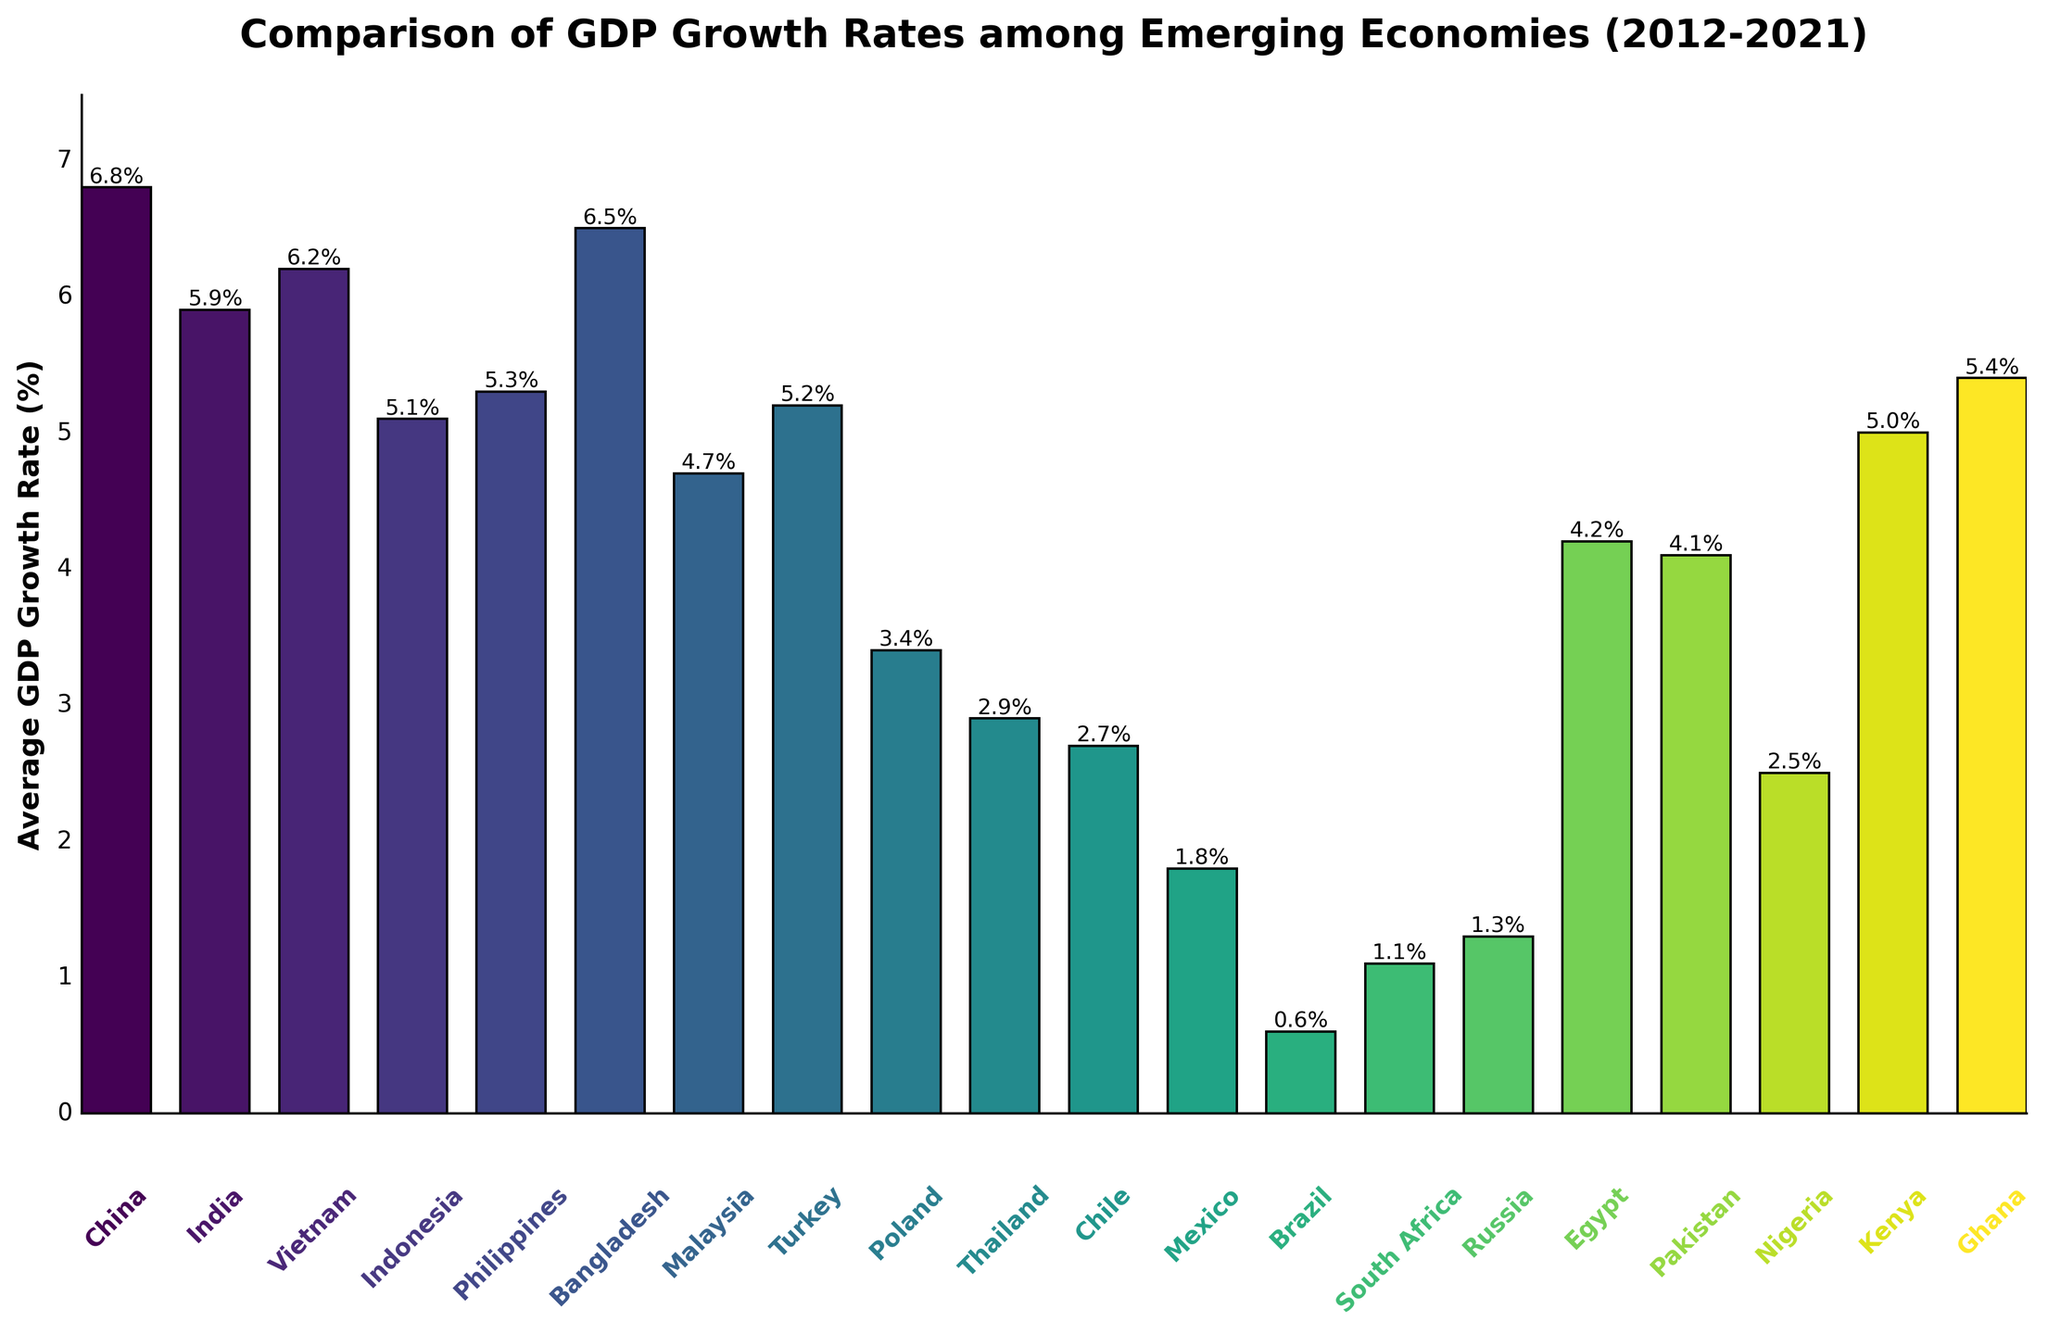What's the average GDP growth rate of China and India combined? To find the average, sum the growth rates of China and India, then divide by 2. For China and India, it's (6.8 + 5.9) / 2 = 12.7 / 2 = 6.35
Answer: 6.35 Which country has the second-highest GDP growth rate? The highest GDP growth rate is China at 6.8%, followed by Bangladesh at 6.5%. So, Bangladesh has the second-highest GDP growth rate.
Answer: Bangladesh What is the total GDP growth rate for Brazil, South Africa, and Russia combined? Sum the growth rates of Brazil, South Africa, and Russia. For these countries, it's 0.6 + 1.1 + 1.3 = 3.0
Answer: 3.0 How much higher is China's GDP growth rate compared to Poland's? Subtract the growth rate of Poland from that of China. For China and Poland, it's 6.8 - 3.4 = 3.4
Answer: 3.4 Which country has a higher GDP growth rate, Nigeria or Kenya? Compare the GDP growth rates of Nigeria and Kenya. Nigeria's growth rate is 2.5%, while Kenya's is 5.0%. Kenya has a higher growth rate.
Answer: Kenya How many countries have a GDP growth rate of more than 5%? Count the countries that have a GDP growth rate greater than 5%. The countries are China, India, Vietnam, Bangladesh, Philippines, Turkey, Kenya, and Ghana, totaling to 8.
Answer: 8 Which bar is the tallest on the chart? Visually inspect the bars to find that the bar representing China is the tallest since it corresponds to the highest growth rate of 6.8%.
Answer: China What is the difference in GDP growth rate between Bangladesh and Malaysia? Subtract the growth rate of Malaysia from Bangladesh. For these countries, it's 6.5 - 4.7 = 1.8
Answer: 1.8 What is the median GDP growth rate among the countries listed? To find the median, list the growth rates in ascending order and find the middle value. With 19 countries, the median is the 10th value, which is 4.7% (Malaysia).
Answer: 4.7 Compare the GDP growth rates of the countries with the three highest values. List the three highest growth rates: China (6.8%), Bangladesh (6.5%), and Vietnam (6.2%), then compare them. All are above 6%, with China being the highest.
Answer: China, Bangladesh, Vietnam 